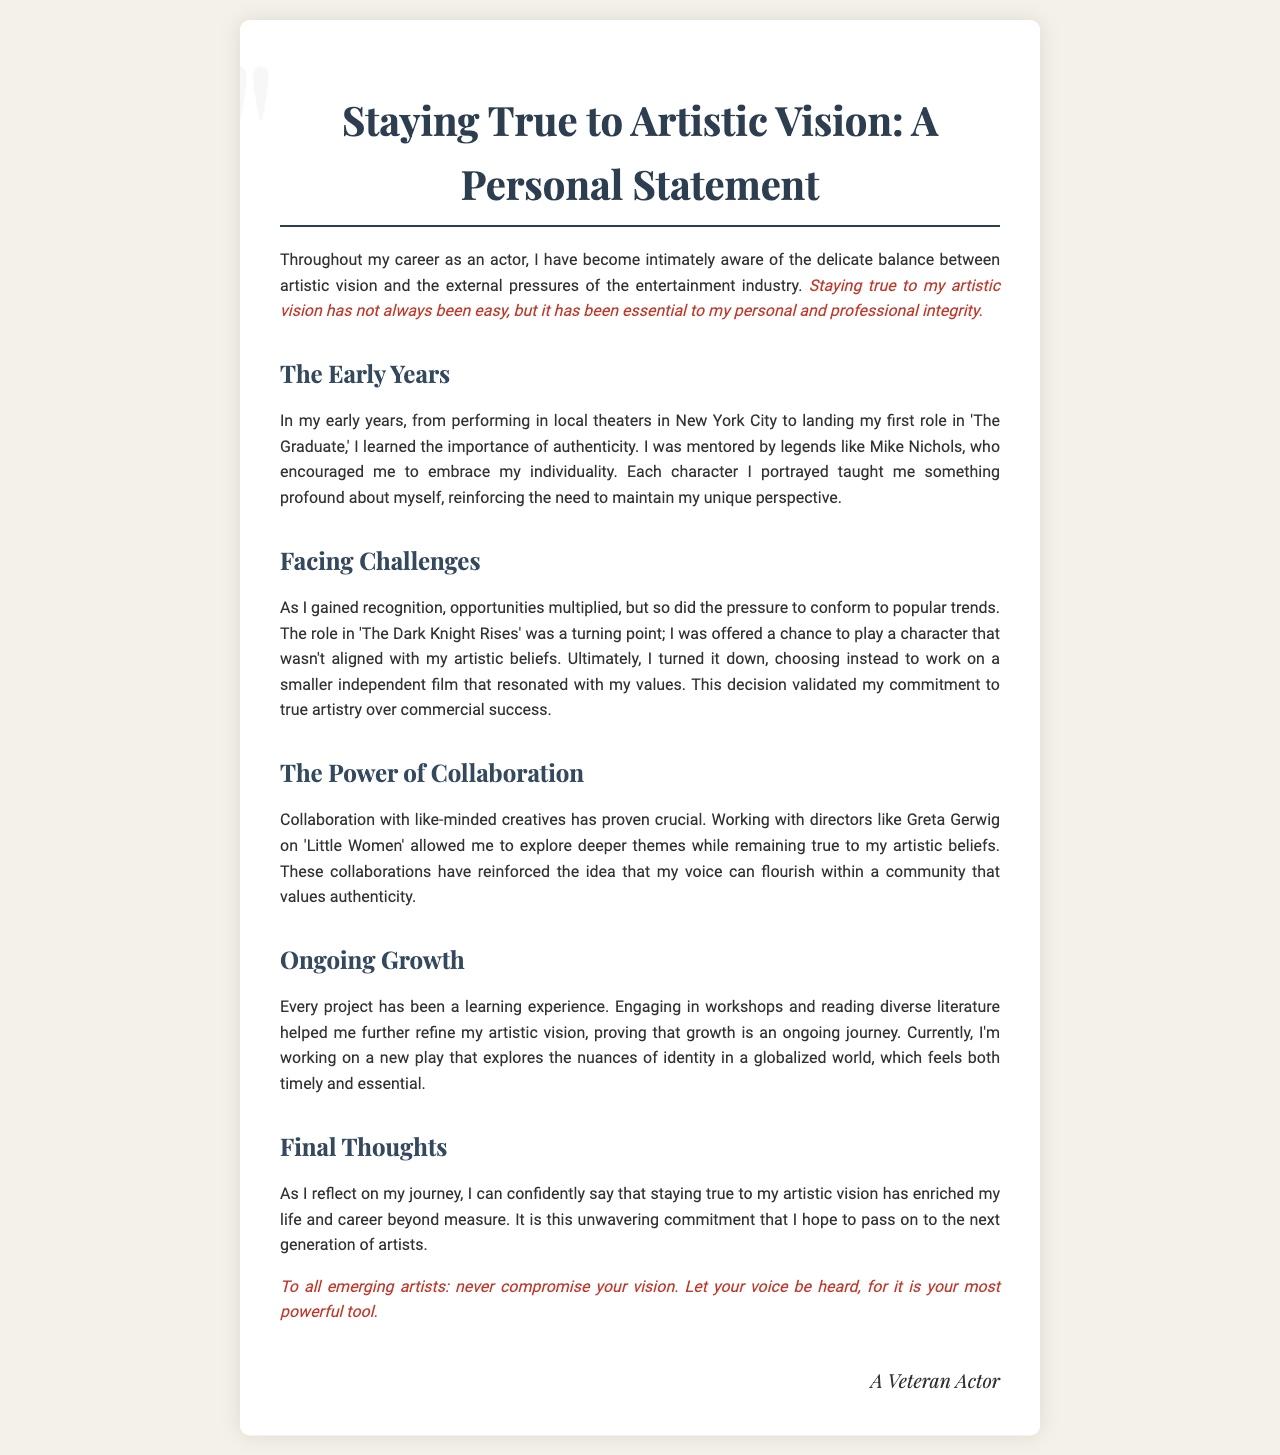What is the title of the letter? The title is explicitly stated at the top of the document, indicating the main theme of the letter.
Answer: Staying True to Artistic Vision: A Personal Statement Who mentored the actor in their early years? The document mentions a specific individual who provided guidance and mentorship during the actor's formative years.
Answer: Mike Nichols What role did the actor turn down? The letter specifies a particular project that the actor chose not to pursue due to artistic misalignment.
Answer: The Dark Knight Rises Which director did the actor collaborate with on 'Little Women'? The letter references a notable collaboration that helped the actor explore deeper themes.
Answer: Greta Gerwig What is the actor currently working on? The document describes an ongoing project that the actor finds relevant and meaningful in their artistic journey.
Answer: A new play What is emphasized as a powerful tool for artists? The document contains a specific phrase that highlights an essential aspect of being an artist.
Answer: Your voice What does the actor encourage emerging artists to do? The letter provides advice directed at the new generation of artists, emphasizing the importance of maintaining a particular aspect of their work.
Answer: Never compromise your vision What theme is explored in the actor's current project? The letter indicates the subject matter of the actor's current artistic endeavor.
Answer: Identity in a globalized world What has enriched the actor's life and career? The document describes what the actor believes has significantly contributed to their professional journey.
Answer: Staying true to my artistic vision 